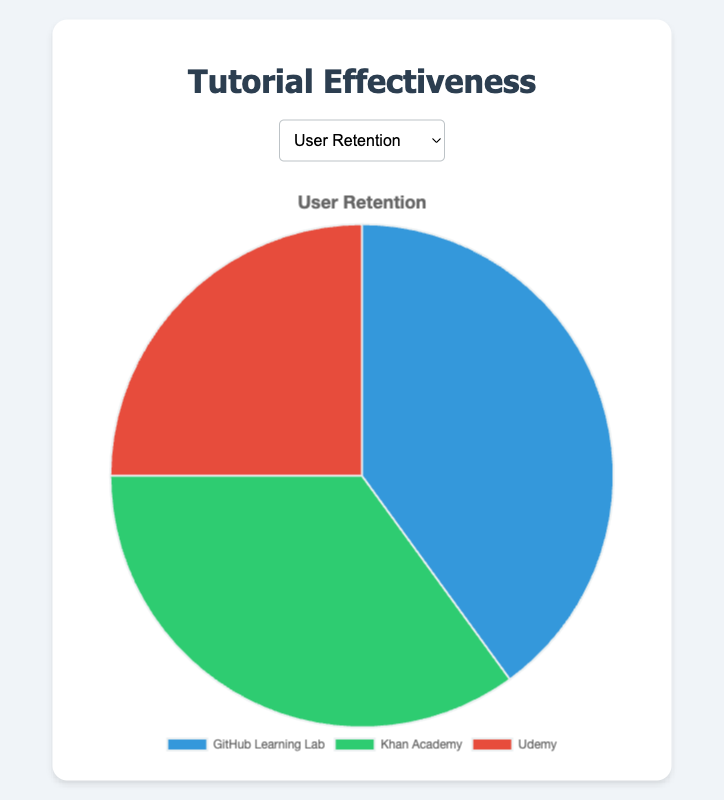What is the highest percentage recorded for User Retention? The pie chart for User Retention shows three percentages: 40%, 35%, and 25%. The highest percentage among these is 40%.
Answer: 40% Which tutorial has the lowest User Satisfaction percentage? The pie chart for User Satisfaction displays three values: 45%, 30%, and 25%. The lowest percentage among these is 25%, which corresponds to Udemy.
Answer: Udemy What is the difference in Understandability percentage between GitHub Learning Lab and Udemy? The Understandability pie chart shows that GitHub Learning Lab has 50% and Udemy 15%. The difference is 50% - 15% = 35%.
Answer: 35% How does Khan Academy's User Retention compare to Udemy's? The pie chart for User Retention shows Khan Academy at 35% and Udemy at 25%. Therefore, Khan Academy's User Retention is greater than Udemy's by 10%.
Answer: 10% What is the total percentage of User Satisfaction for all three tutorials? The pie chart for User Satisfaction shows percentages of 45%, 30%, and 25%. Summing these up: 45% + 30% + 25% = 100%.
Answer: 100% Which tutorial has the highest Understandability percentage? The Understandability pie chart shows percentages of 50%, 35%, and 15%. The highest percentage is 50%, corresponding to GitHub Learning Lab.
Answer: GitHub Learning Lab If we combine the User Retention percentages of Khan Academy and Udemy, how does the resulting percentage compare to GitHub Learning Lab's User Retention? Khan Academy's User Retention is 35% and Udemy's is 25%. Summing these up: 35% + 25% = 60%. GitHub Learning Lab's User Retention is 40%, so the combined percentage is 20% greater than GitHub Learning Lab's.
Answer: 20% What color represents the GitHub Learning Lab in the Understandability chart? In the Understandability pie chart, the GitHub Learning Lab's percentage follows the first label and is visually represented by the color blue.
Answer: blue Which metric shows the highest percentage for Khan Academy? The pie charts indicate that Khan Academy's percentages are 35% for User Retention, 30% for User Satisfaction, and 35% for Understandability. The highest percentage, 35%, is shared by User Retention and Understandability.
Answer: User Retention and Understandability Is Udemy's Understandability higher or lower than its User Retention? The Understandability pie chart shows Udemy at 15%, and the User Retention pie chart shows 25%. Udemy's Understandability is lower than its User Retention by 10%.
Answer: lower 